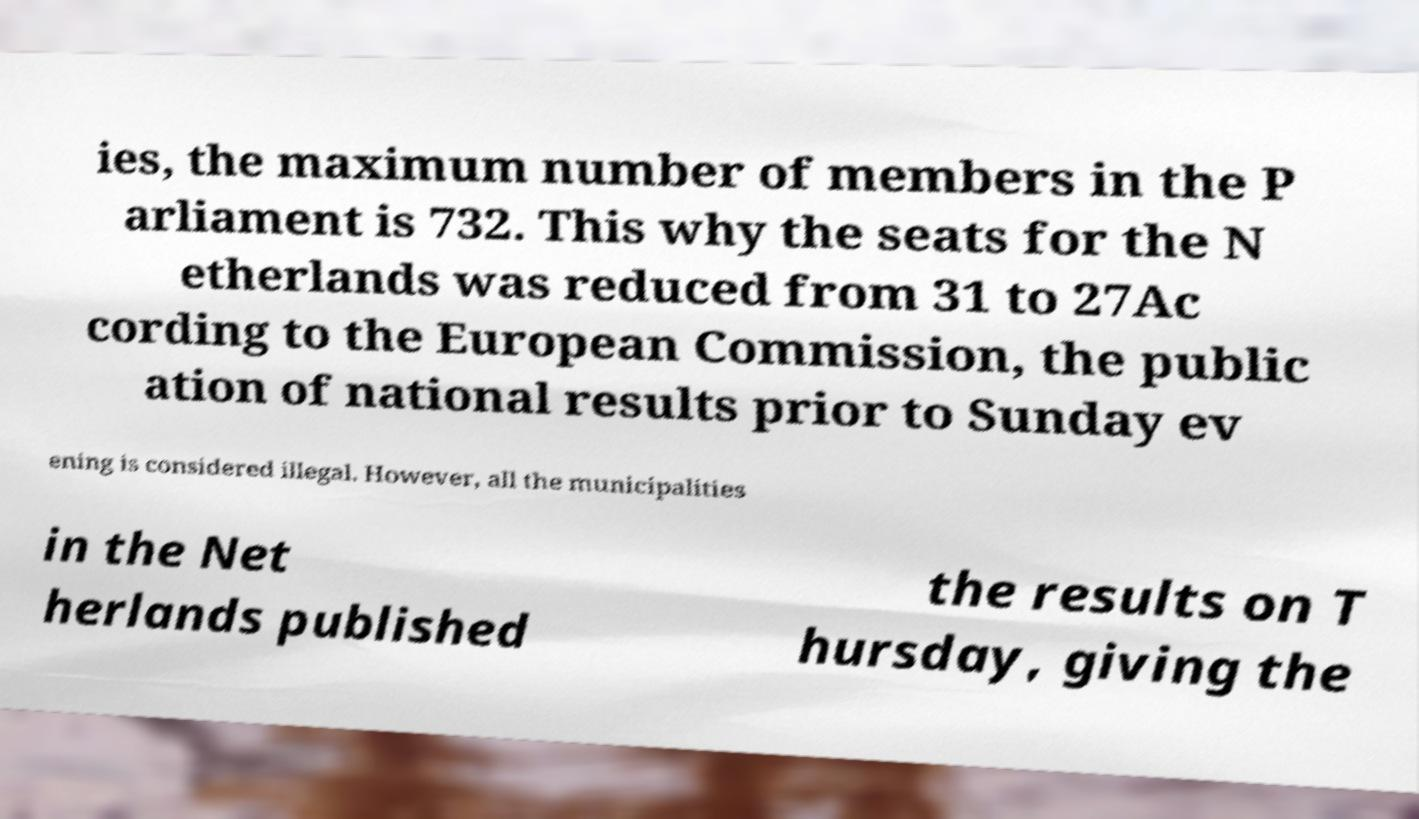Can you read and provide the text displayed in the image?This photo seems to have some interesting text. Can you extract and type it out for me? ies, the maximum number of members in the P arliament is 732. This why the seats for the N etherlands was reduced from 31 to 27Ac cording to the European Commission, the public ation of national results prior to Sunday ev ening is considered illegal. However, all the municipalities in the Net herlands published the results on T hursday, giving the 